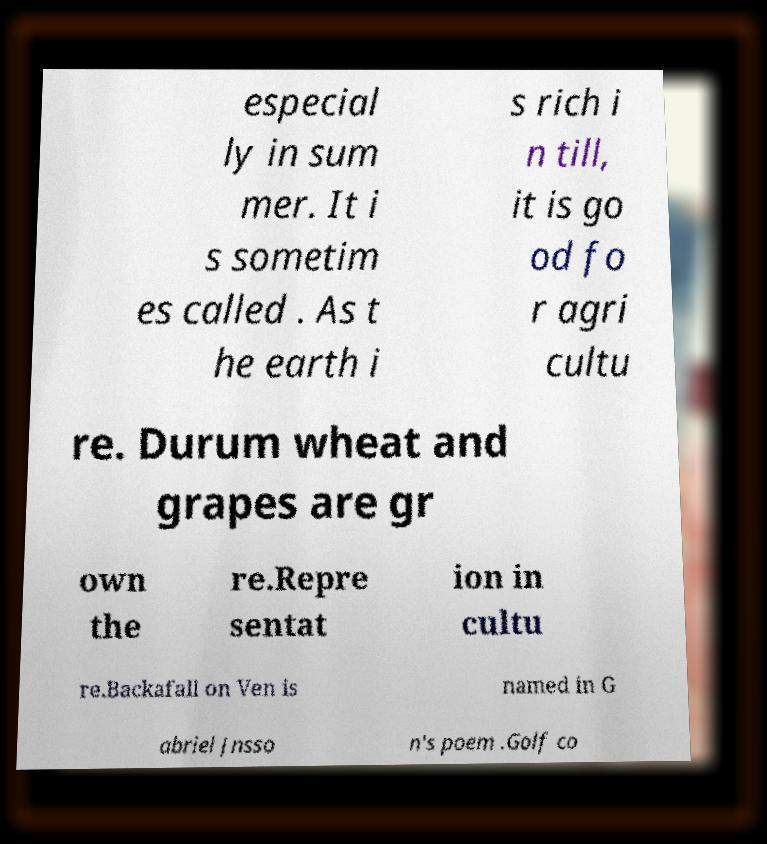I need the written content from this picture converted into text. Can you do that? especial ly in sum mer. It i s sometim es called . As t he earth i s rich i n till, it is go od fo r agri cultu re. Durum wheat and grapes are gr own the re.Repre sentat ion in cultu re.Backafall on Ven is named in G abriel Jnsso n's poem .Golf co 